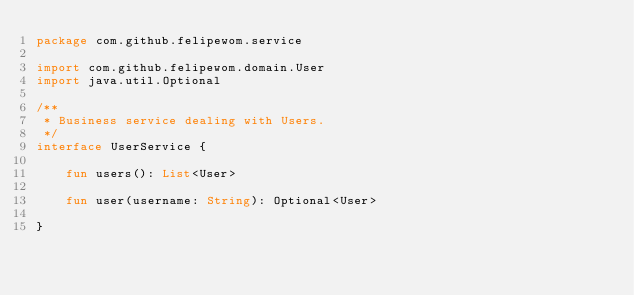<code> <loc_0><loc_0><loc_500><loc_500><_Kotlin_>package com.github.felipewom.service

import com.github.felipewom.domain.User
import java.util.Optional

/**
 * Business service dealing with Users.
 */
interface UserService {

    fun users(): List<User>

    fun user(username: String): Optional<User>

}
</code> 